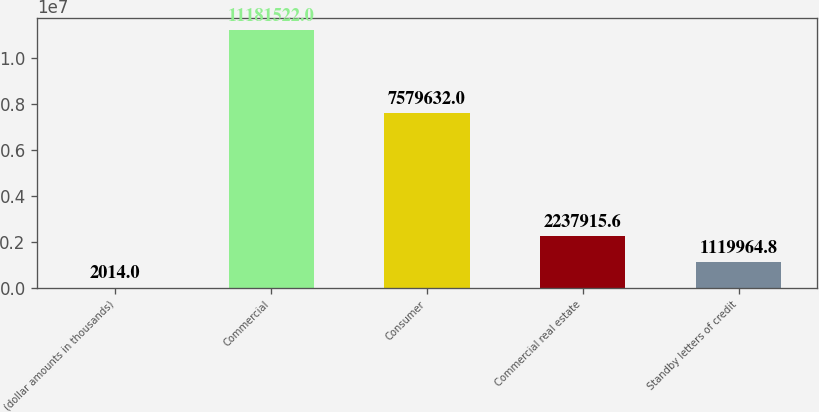<chart> <loc_0><loc_0><loc_500><loc_500><bar_chart><fcel>(dollar amounts in thousands)<fcel>Commercial<fcel>Consumer<fcel>Commercial real estate<fcel>Standby letters of credit<nl><fcel>2014<fcel>1.11815e+07<fcel>7.57963e+06<fcel>2.23792e+06<fcel>1.11996e+06<nl></chart> 